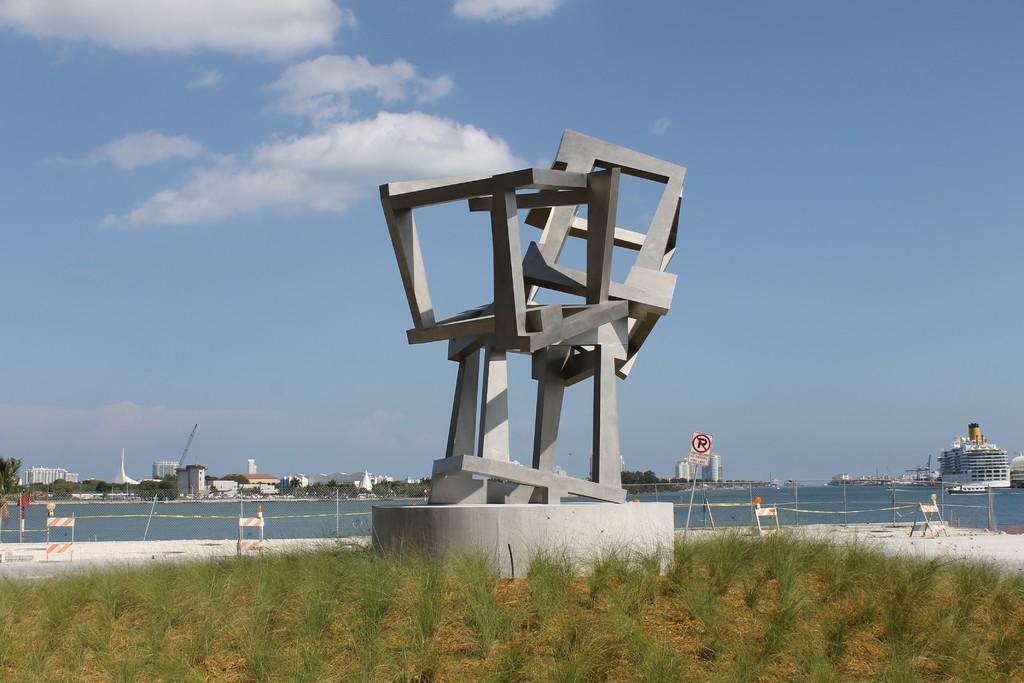Could you give a brief overview of what you see in this image? In this image I can see the concrete structure and the grass. To the side I can see the fence, sign board and the water. In the background I can see the buildings, trees, clouds and the sky. 